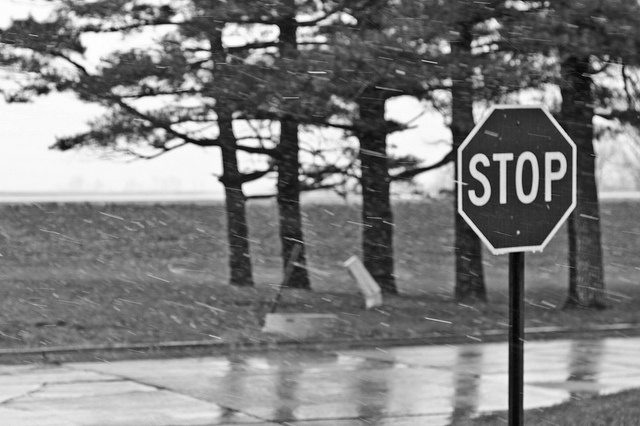Describe the objects in this image and their specific colors. I can see a stop sign in white, black, lightgray, gray, and darkgray tones in this image. 